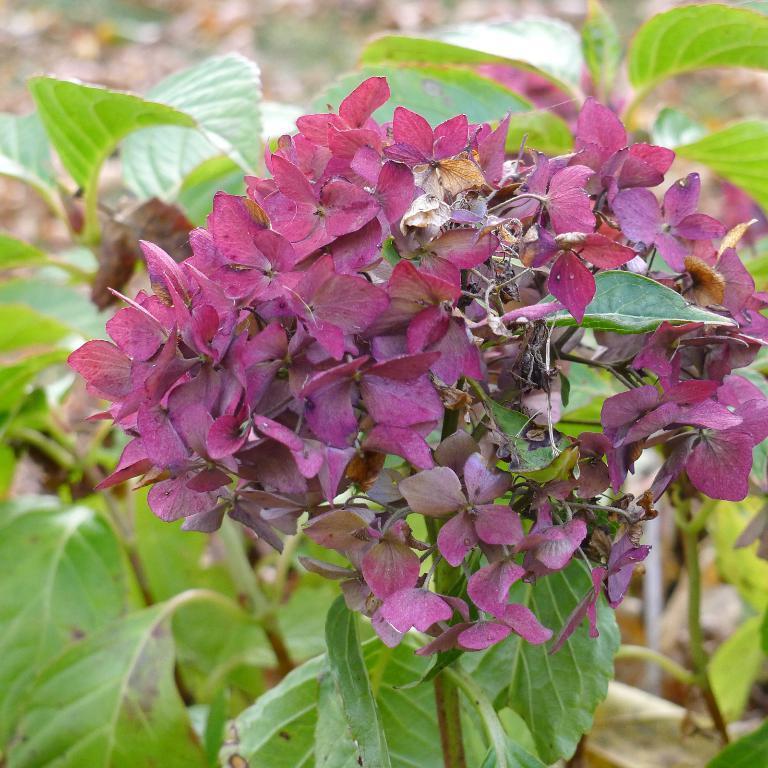Could you give a brief overview of what you see in this image? In the image we can see some flowers and plants. 